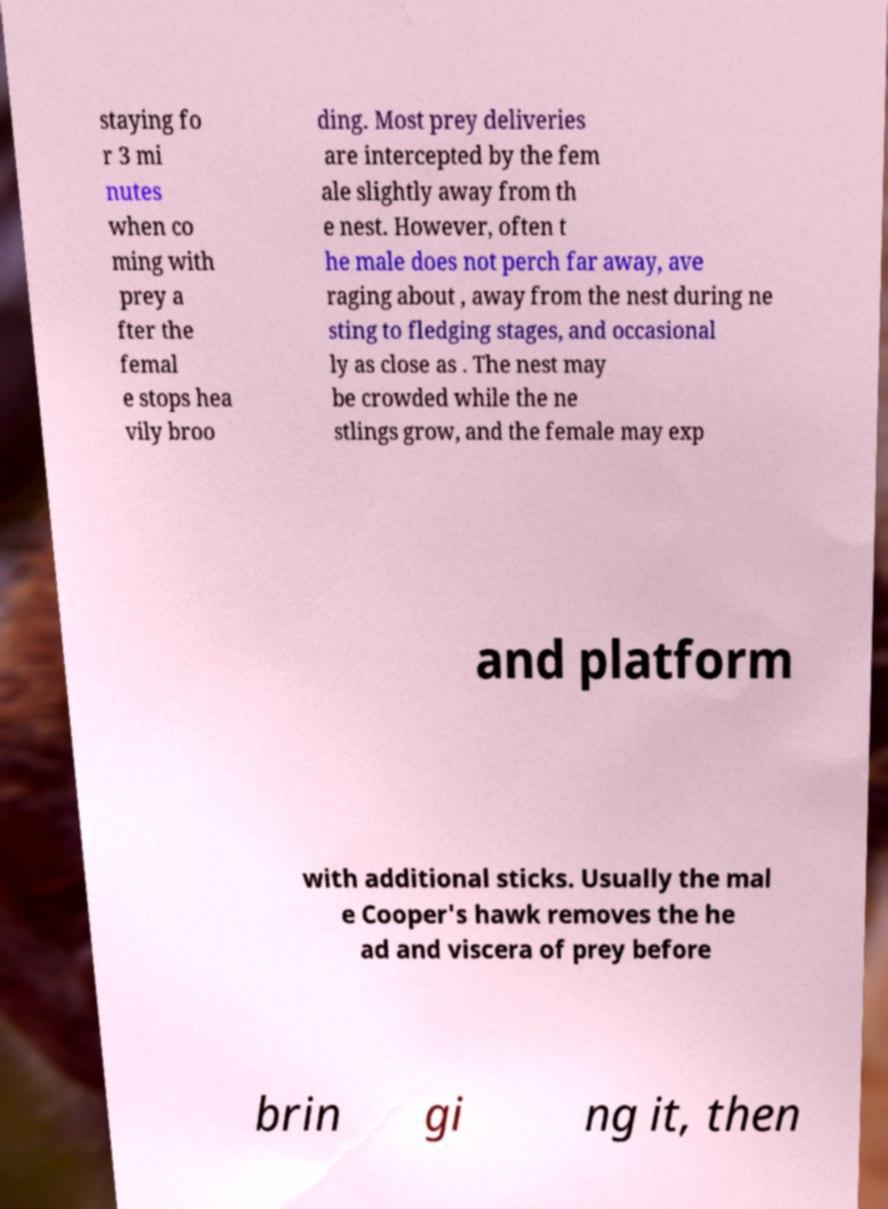Please read and relay the text visible in this image. What does it say? staying fo r 3 mi nutes when co ming with prey a fter the femal e stops hea vily broo ding. Most prey deliveries are intercepted by the fem ale slightly away from th e nest. However, often t he male does not perch far away, ave raging about , away from the nest during ne sting to fledging stages, and occasional ly as close as . The nest may be crowded while the ne stlings grow, and the female may exp and platform with additional sticks. Usually the mal e Cooper's hawk removes the he ad and viscera of prey before brin gi ng it, then 